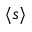<formula> <loc_0><loc_0><loc_500><loc_500>\langle s \rangle</formula> 